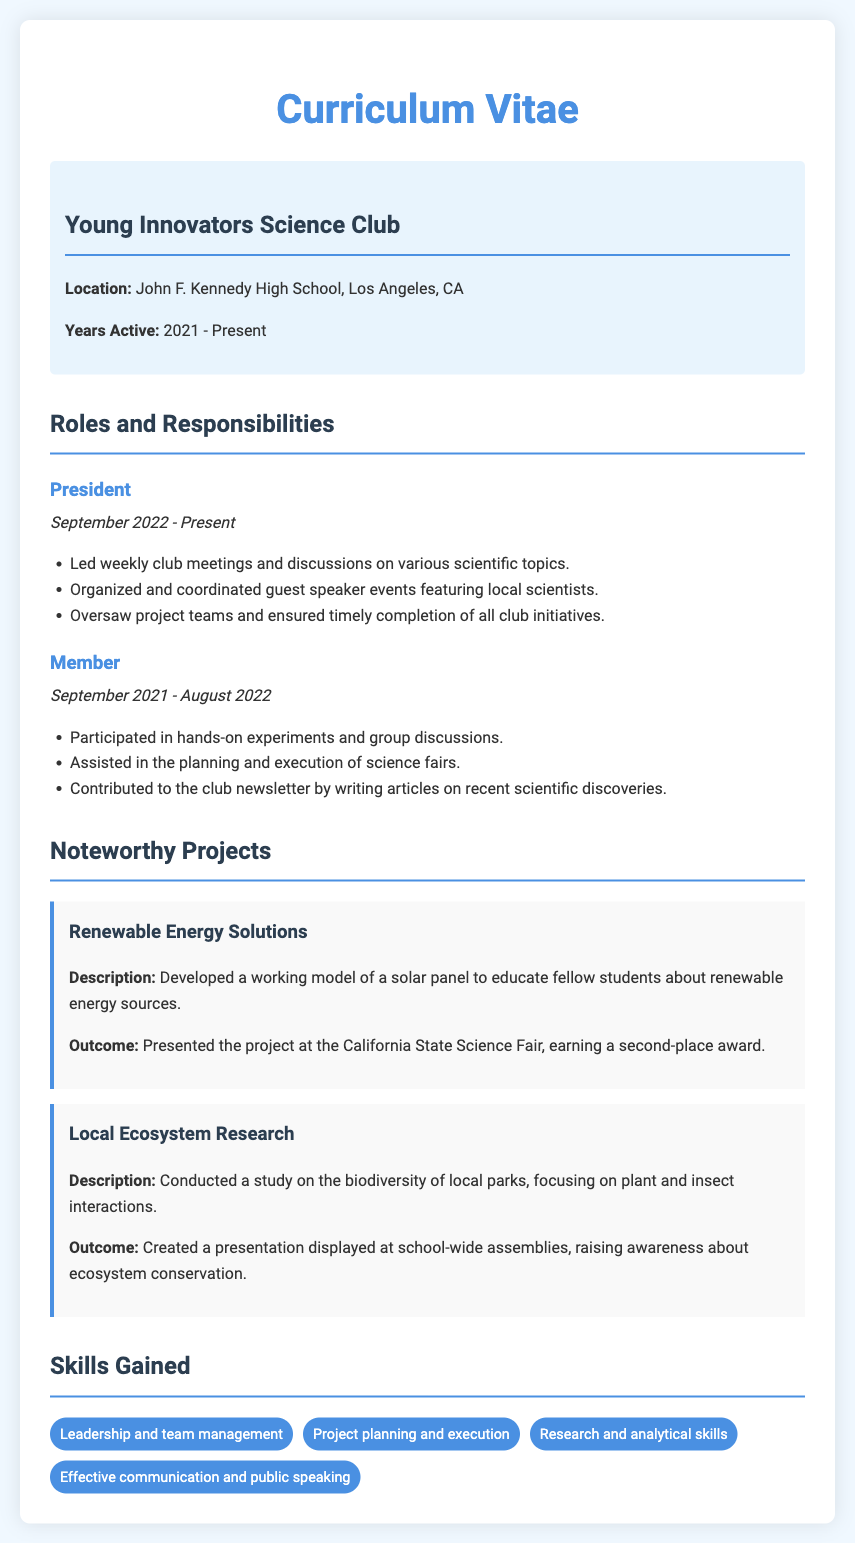What is the name of the science club? The name of the science club is mentioned in the document header.
Answer: Young Innovators Science Club When did the club membership start? The starting date of the club membership is at the beginning of the document.
Answer: September 2021 Who is the current president of the club? The current president is listed under the roles and responsibilities section.
Answer: President What significant project earned a second-place award? This project is described in the noteworthy projects section with its outcome.
Answer: Renewable Energy Solutions What type of model was developed in the Renewable Energy Solutions project? The type of model is specified in the project description.
Answer: Solar panel What skills are highlighted in the skills gained section? The section lists specific skills obtained through club participation.
Answer: Leadership and team management How many years has the Young Innovators Science Club been active? The years active section presents the time frame of the club's existence.
Answer: 3 years What role did the individual hold before becoming president? The roles and responsibilities outline the sequence of roles held.
Answer: Member What event involved raising awareness about ecosystem conservation? The event is detailed in the outcomes of a noteworthy project.
Answer: School-wide assemblies 